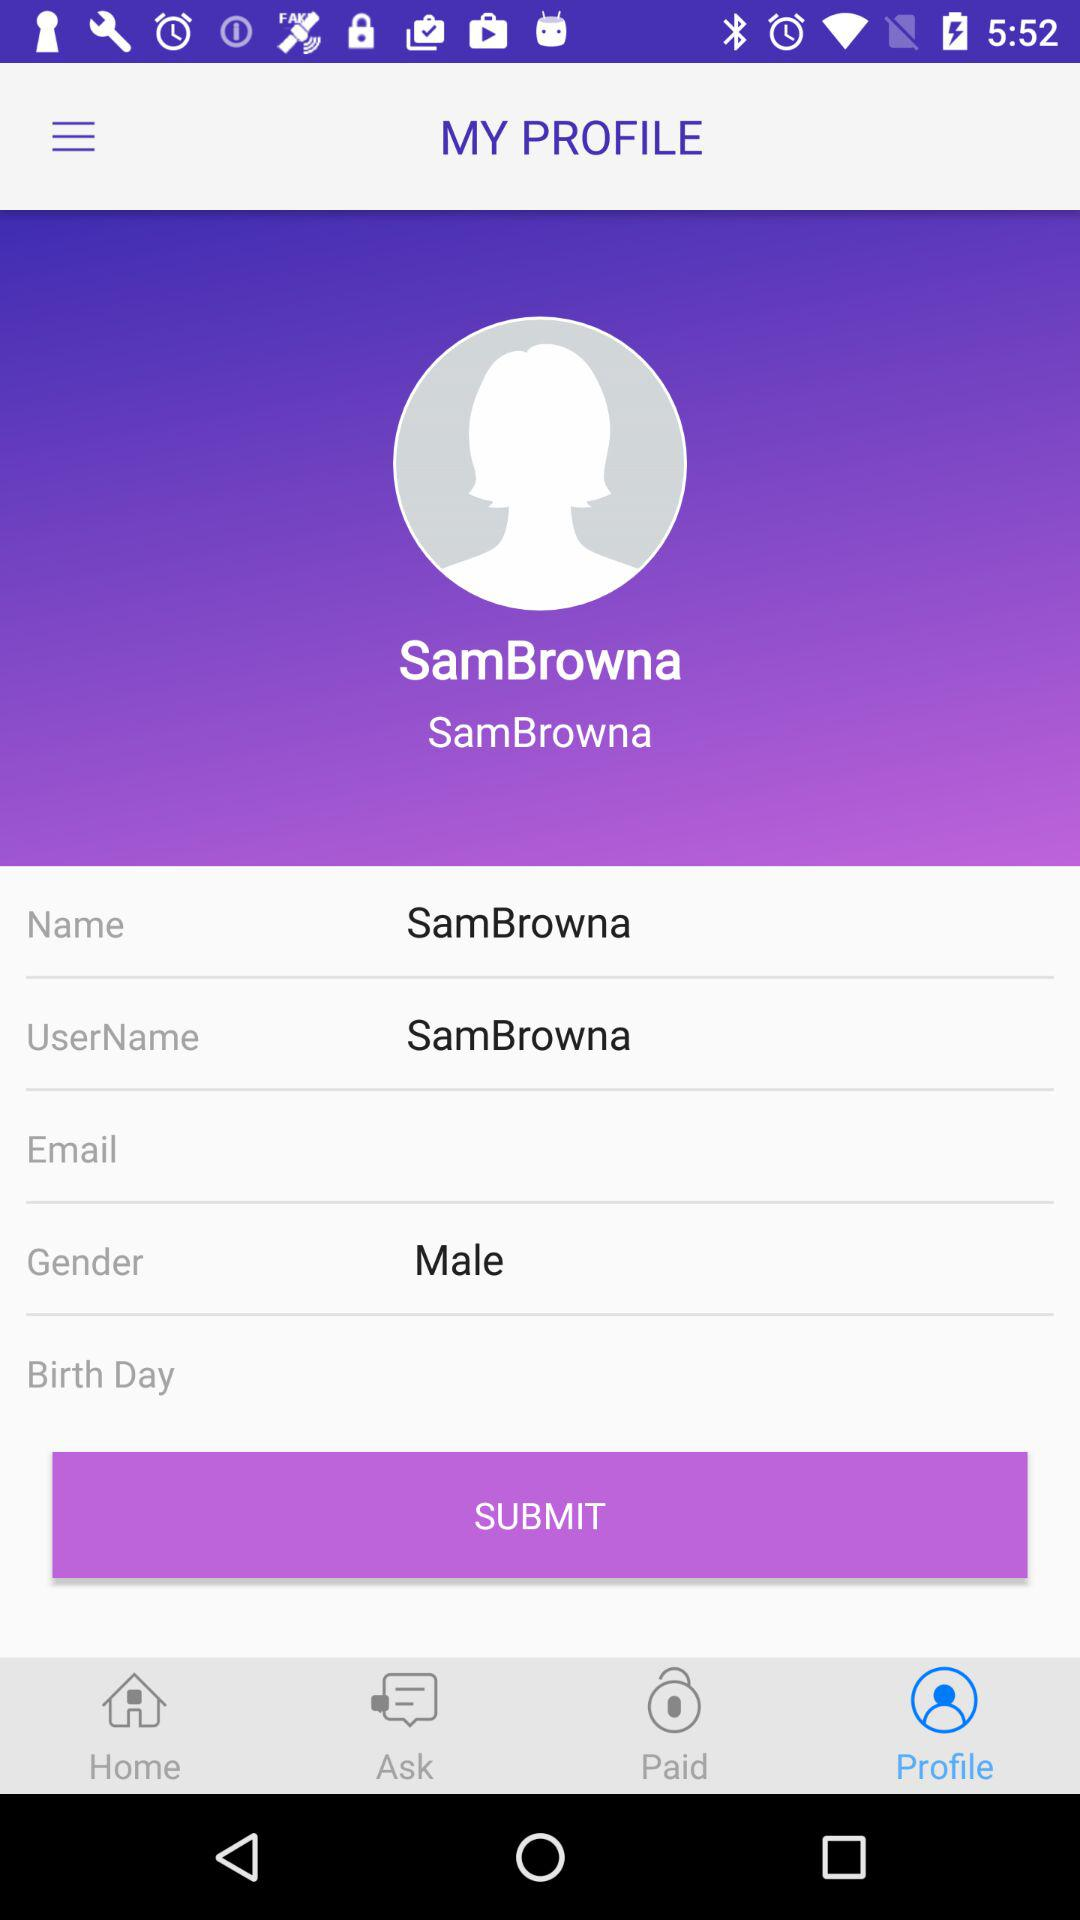When was the most recent question asked?
When the provided information is insufficient, respond with <no answer>. <no answer> 